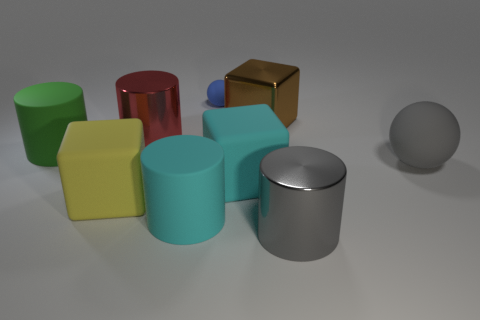Subtract 1 cylinders. How many cylinders are left? 3 Subtract all cyan cylinders. How many cylinders are left? 3 Subtract all gray cylinders. How many cylinders are left? 3 Subtract all blue cylinders. Subtract all brown cubes. How many cylinders are left? 4 Add 1 blue metallic blocks. How many objects exist? 10 Subtract all spheres. How many objects are left? 7 Add 7 cyan cylinders. How many cyan cylinders exist? 8 Subtract 0 brown cylinders. How many objects are left? 9 Subtract all large rubber balls. Subtract all metallic cylinders. How many objects are left? 6 Add 9 yellow matte objects. How many yellow matte objects are left? 10 